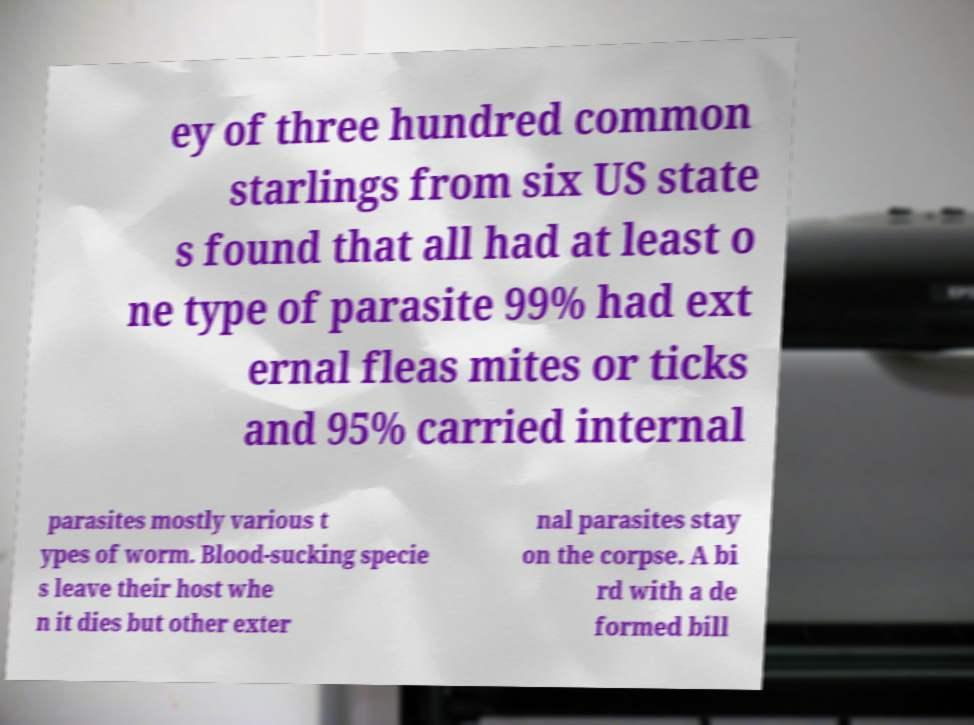Could you extract and type out the text from this image? ey of three hundred common starlings from six US state s found that all had at least o ne type of parasite 99% had ext ernal fleas mites or ticks and 95% carried internal parasites mostly various t ypes of worm. Blood-sucking specie s leave their host whe n it dies but other exter nal parasites stay on the corpse. A bi rd with a de formed bill 